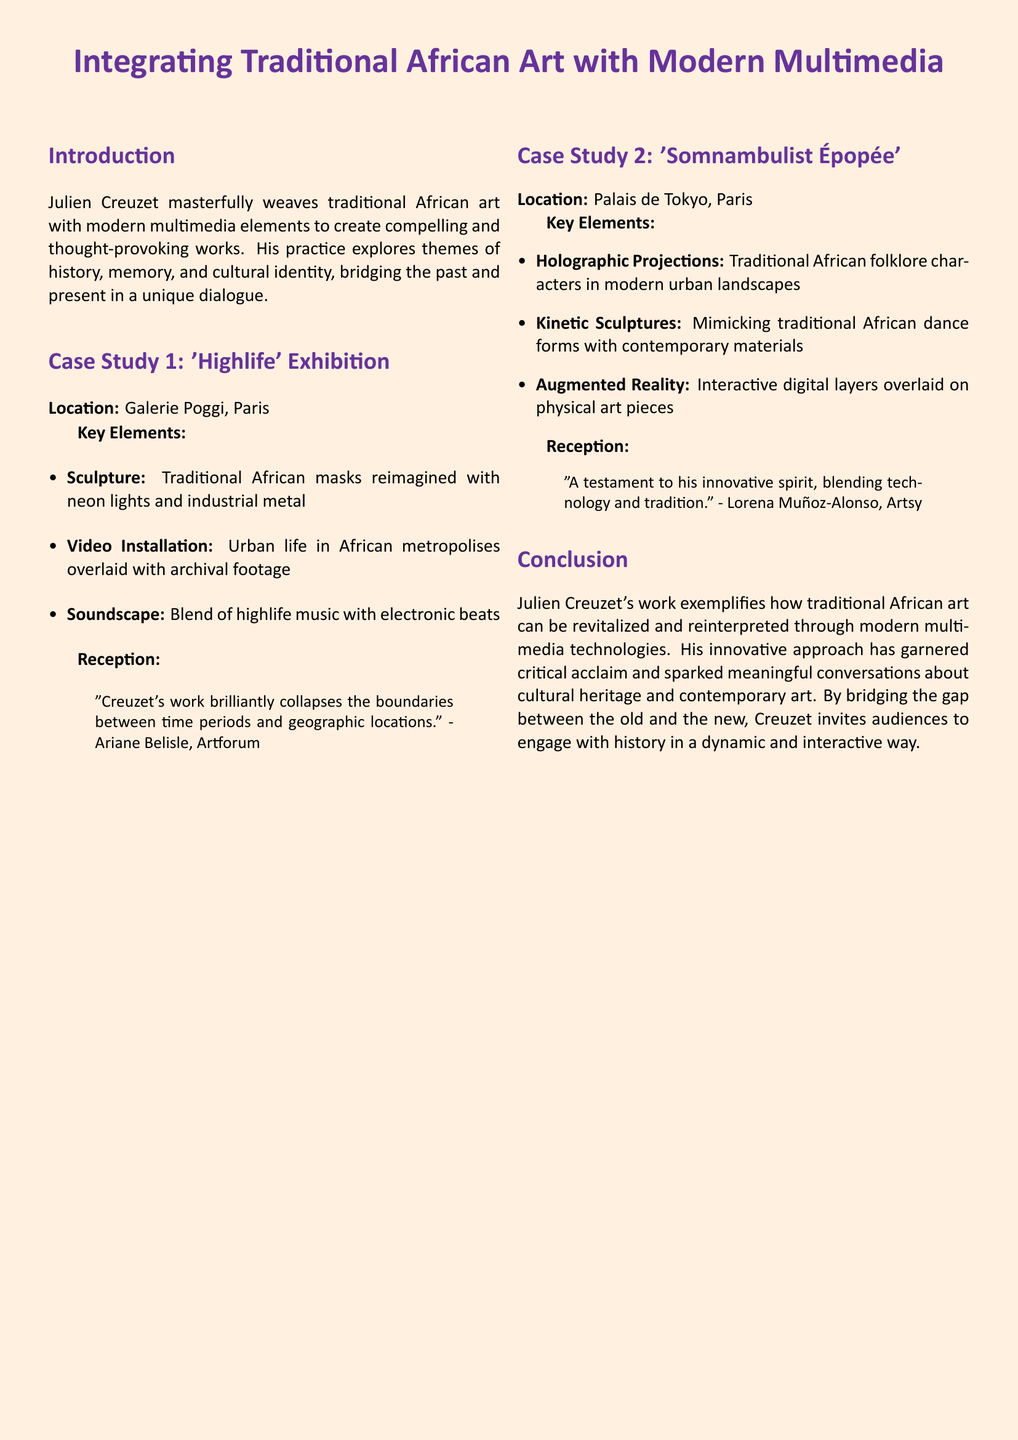What is the title of the case study? The title is prominently featured in the document as a main title.
Answer: Integrating Traditional African Art with Modern Multimedia Where was the 'Highlife' exhibition located? The location is stated right after the title of the first case study.
Answer: Galerie Poggi, Paris What type of music is included in the soundscape of 'Highlife'? The specific type of music mentioned in the case study is part of the key elements listed.
Answer: Highlife music What innovative technology is used in 'Somnambulist Épopée'? The technologies used in the second case study are listed under key elements.
Answer: Holographic Projections Who praised Creuzet’s work in Artforum? The name of the person is mentioned in the reception section of the first case study.
Answer: Ariane Belisle What are the kinetic sculptures in 'Somnambulist Épopée' mimicking? The function of the kinetic sculptures is briefly described in the document.
Answer: Traditional African dance forms What overarching theme does Creuzet's work explore? The theme is introduced in the introduction section summarizing the essence of Creuzet's practice.
Answer: Cultural identity Which city hosted both case studies discussed? The city is referred to in both case studies, indicating the common location.
Answer: Paris 